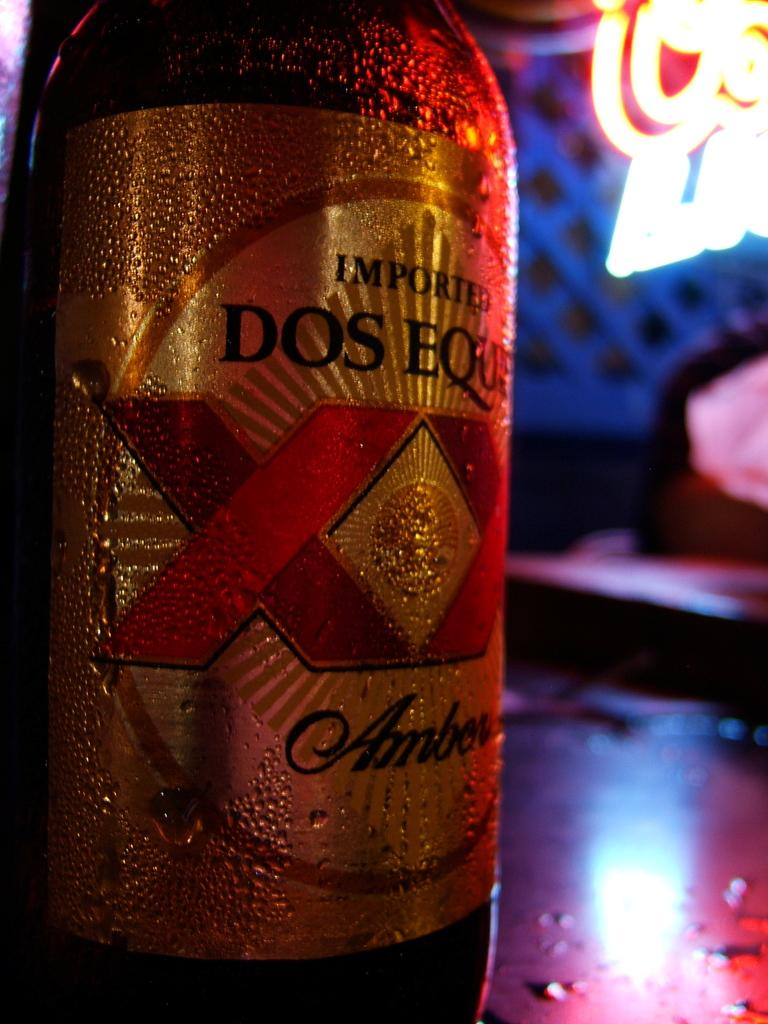<image>
Create a compact narrative representing the image presented. A bottle with beads of condensation has the word Amber towards the bottom of the label. 